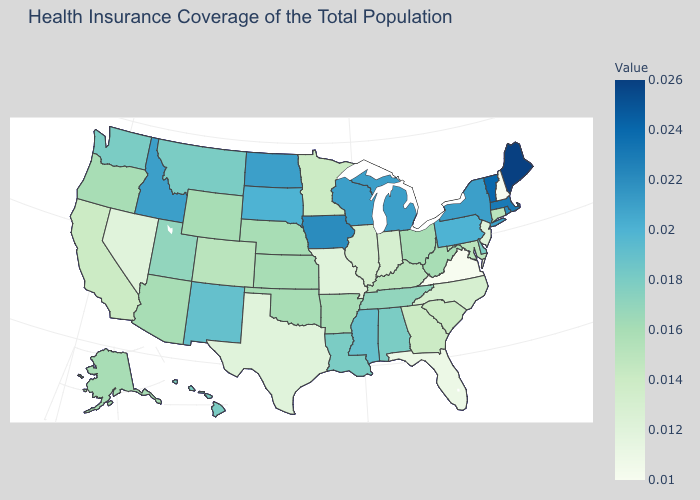Does the map have missing data?
Give a very brief answer. No. Does Connecticut have the highest value in the USA?
Be succinct. No. Does Indiana have the lowest value in the MidWest?
Short answer required. No. Which states have the lowest value in the USA?
Write a very short answer. New Hampshire, Virginia. Among the states that border Indiana , does Michigan have the highest value?
Short answer required. Yes. Which states have the lowest value in the USA?
Write a very short answer. New Hampshire, Virginia. Is the legend a continuous bar?
Be succinct. Yes. 